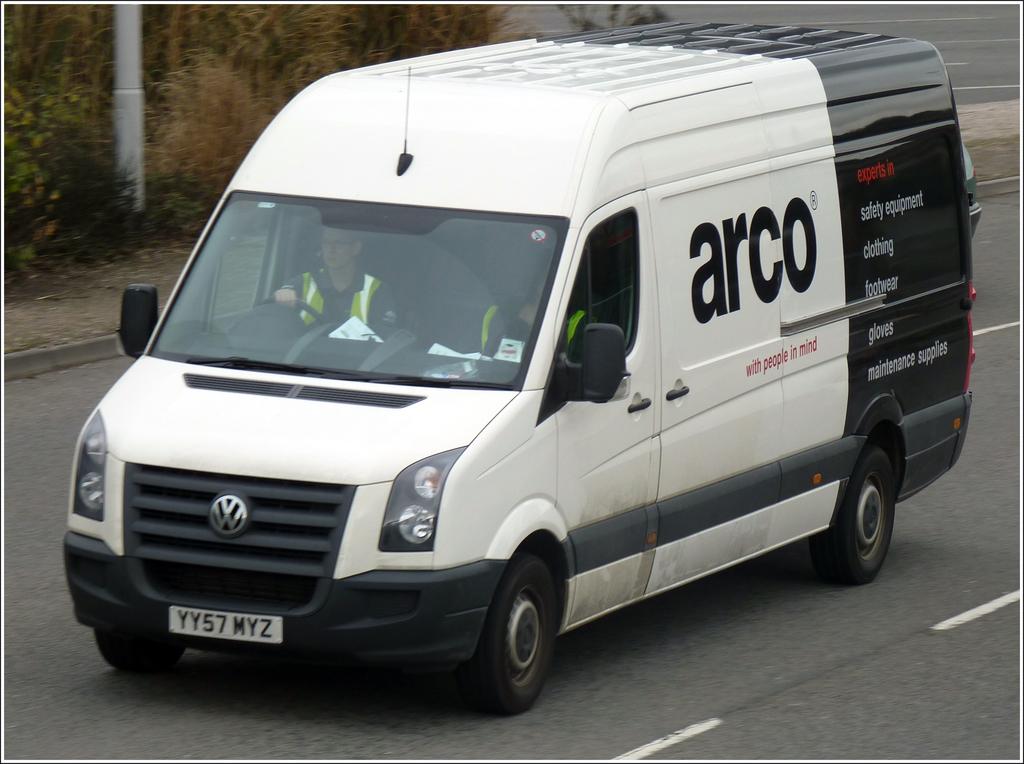What company is this van working with?
Offer a very short reply. Arco. What is the license plate number on this vehicle?
Provide a succinct answer. Yy57myz. 